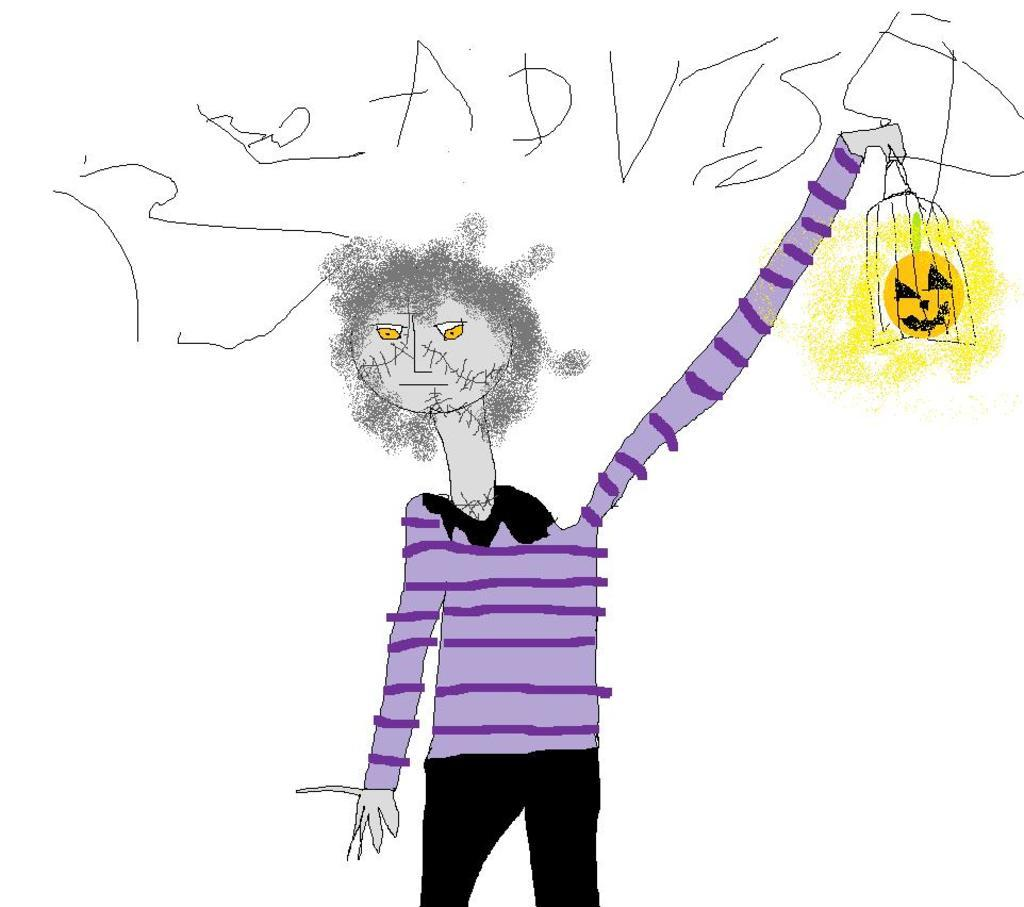What is depicted in the image? There is a drawing of a person in the image. Where is the drawing located in the image? The drawing is located at the bottom of the image. What else can be seen in the image besides the drawing? There is text written in the image. Where is the text located in the image? The text is located at the top of the image. What type of wax is being used by the hen in the image? There is no hen or wax present in the image; it features a drawing of a person and text. 